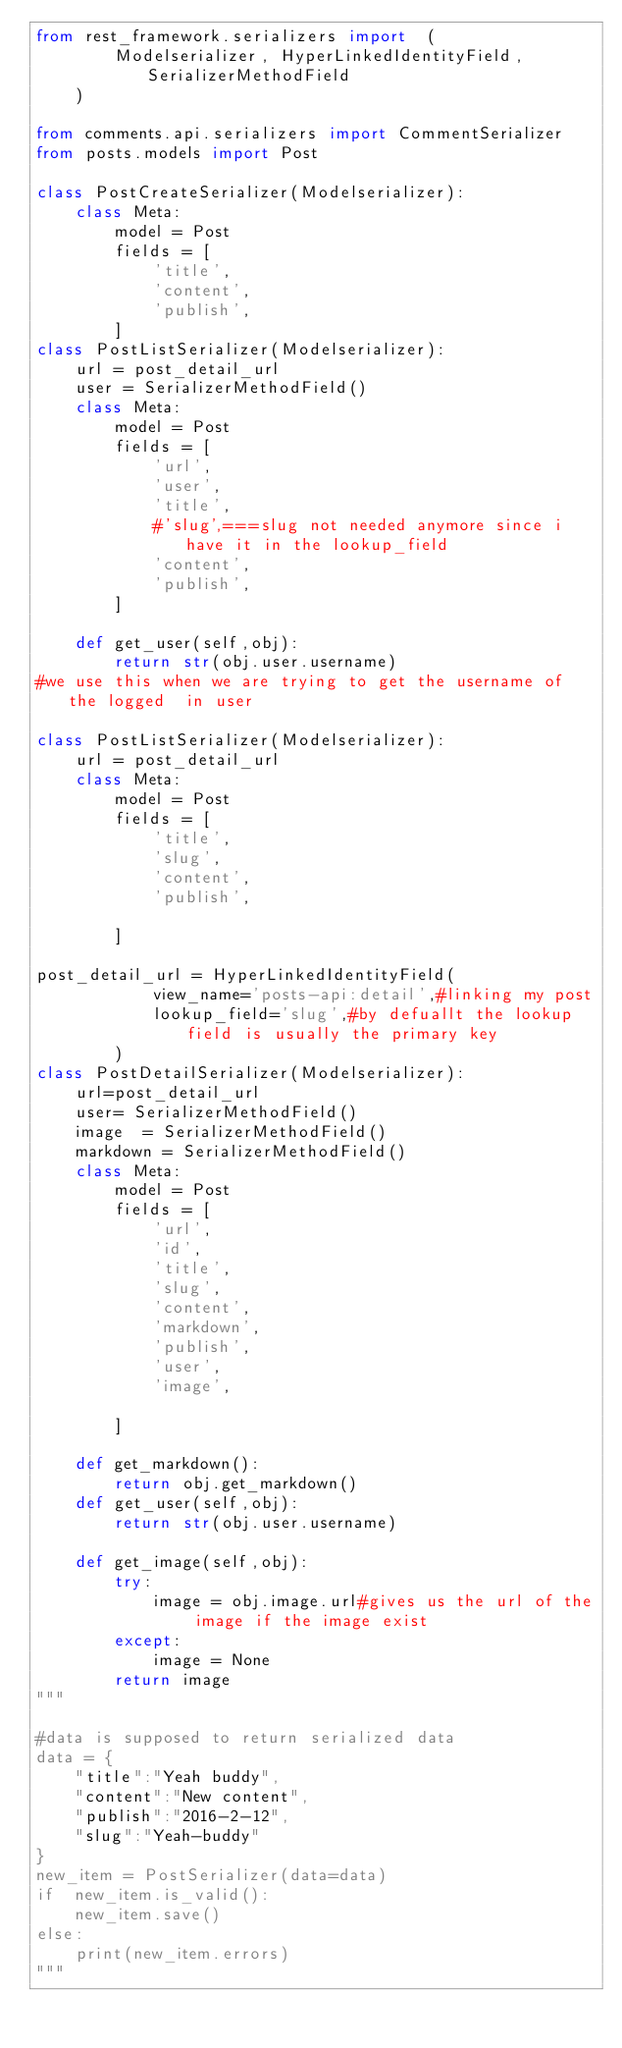Convert code to text. <code><loc_0><loc_0><loc_500><loc_500><_Python_>from rest_framework.serializers import  (
		Modelserializer, HyperLinkedIdentityField,SerializerMethodField
	)

from comments.api.serializers import CommentSerializer
from posts.models import Post

class PostCreateSerializer(Modelserializer):
	class Meta:
		model = Post
		fields = [
			'title',
			'content',
			'publish',
		]
class PostListSerializer(Modelserializer):
	url = post_detail_url
	user = SerializerMethodField()
	class Meta:
		model = Post
		fields = [
			'url',
			'user',
			'title',
			#'slug',===slug not needed anymore since i have it in the lookup_field
			'content',
			'publish',
		]

	def get_user(self,obj):
		return str(obj.user.username)
#we use this when we are trying to get the username of the logged  in user

class PostListSerializer(Modelserializer):
	url = post_detail_url
	class Meta:
		model = Post
		fields = [
			'title',
			'slug',
			'content',
			'publish',

		]

post_detail_url = HyperLinkedIdentityField(
			view_name='posts-api:detail',#linking my post
			lookup_field='slug',#by defuallt the lookup field is usually the primary key
		)
class PostDetailSerializer(Modelserializer):
	url=post_detail_url
	user= SerializerMethodField()
	image  = SerializerMethodField()
	markdown = SerializerMethodField()
	class Meta:
		model = Post
		fields = [
			'url',
			'id',
			'title',
			'slug',
			'content',
			'markdown',
			'publish',
			'user',
			'image',

		]

	def get_markdown():
		return obj.get_markdown()
	def get_user(self,obj):
		return str(obj.user.username)

	def get_image(self,obj):
		try:
			image = obj.image.url#gives us the url of the image if the image exist
		except:
			image = None
		return image
"""

#data is supposed to return serialized data
data = {
	"title":"Yeah buddy",
	"content":"New content",
	"publish":"2016-2-12",
	"slug":"Yeah-buddy"
}
new_item = PostSerializer(data=data)
if  new_item.is_valid():
	new_item.save()
else:
	print(new_item.errors)
"""
</code> 